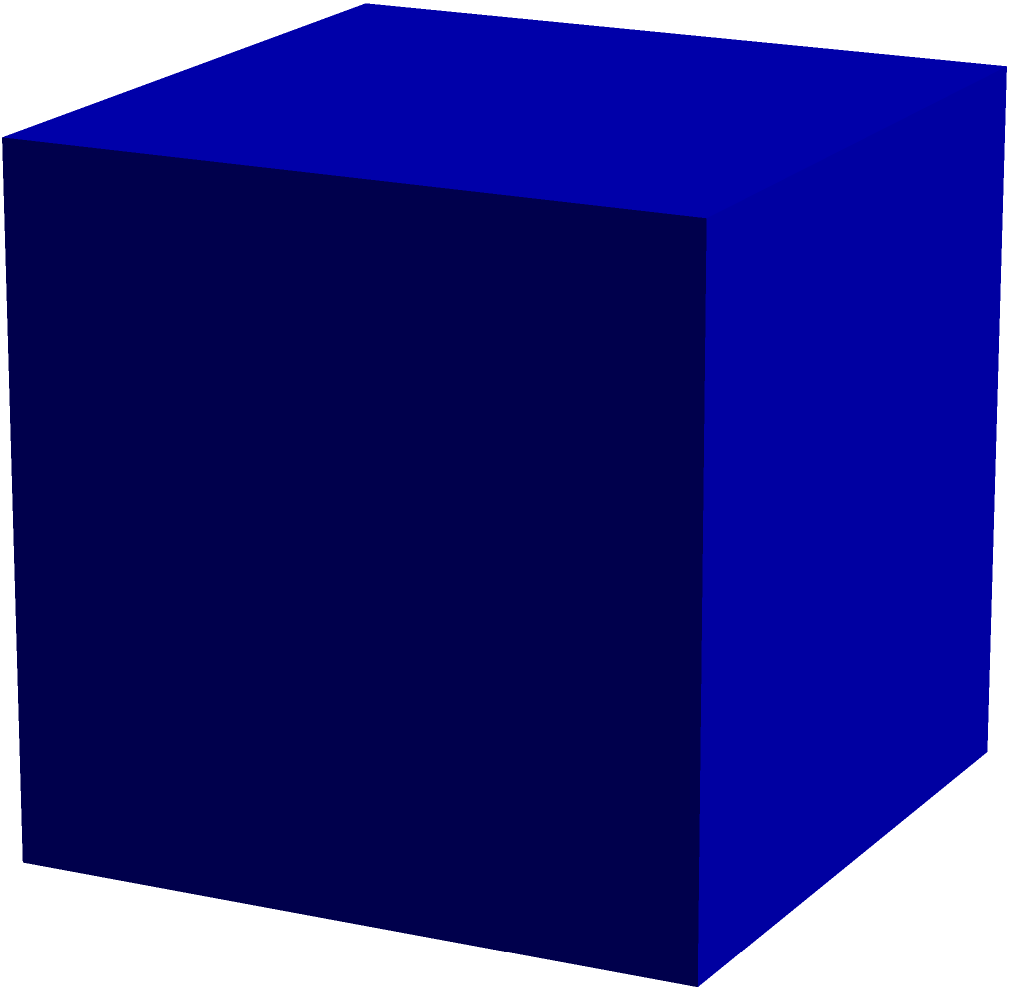As a marketing strategist analyzing online community dynamics, you're developing a model to represent user engagement in a 3D space. If each user's interaction is represented by a cube with edge length $a$, calculate the total surface area of this engagement cube. How might this metric be useful in assessing the depth and breadth of user interaction within your online community? To calculate the surface area of a cube given its edge length $a$, we follow these steps:

1) A cube has 6 faces, all of which are squares.
2) The area of each square face is $a^2$.
3) Therefore, the total surface area is the sum of the areas of all 6 faces.

Let's express this mathematically:

Surface Area $= 6 \times \text{Area of one face}$
$= 6 \times a^2$
$= 6a^2$

In the context of online community dynamics:
- The edge length $a$ could represent the depth of a user's engagement in different aspects (e.g., time spent, content created, interactions).
- The surface area $6a^2$ could represent the total engagement footprint of a user.
- A larger surface area would indicate a user with more extensive and varied interactions within the community.
- This metric could help identify key influencers or highly engaged users who contribute significantly to the community's vibrancy and growth.
Answer: $6a^2$ 